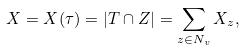Convert formula to latex. <formula><loc_0><loc_0><loc_500><loc_500>X = X ( \tau ) = | T \cap Z | = \sum _ { z \in N _ { v } } X _ { z } ,</formula> 